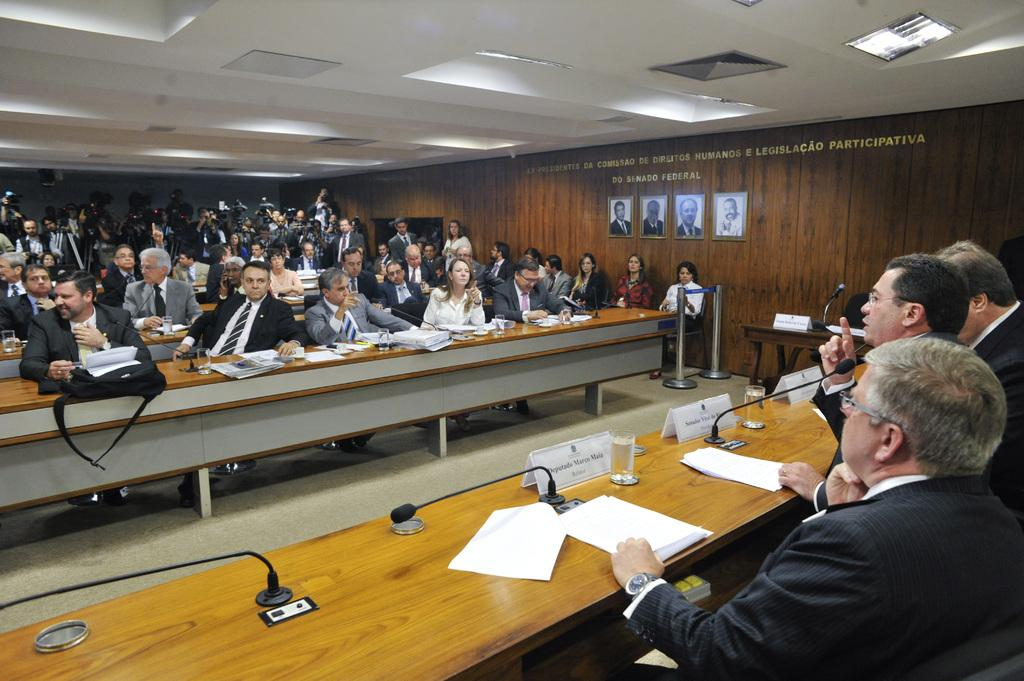What is the seated man doing in the image? The seated man is sitting on a chair on the right side of the image. What is the seated man wearing? The seated man is wearing a black coat. What is the other man doing in the image? The other man is speaking on a microphone beside the seated man. How many persons are sitting on the left side of the image? There are a few persons sitting on the left side of the image. What time of day, the goose is flying in the image? There is no goose present in the image, so it cannot be determined if a goose is flying or not. 